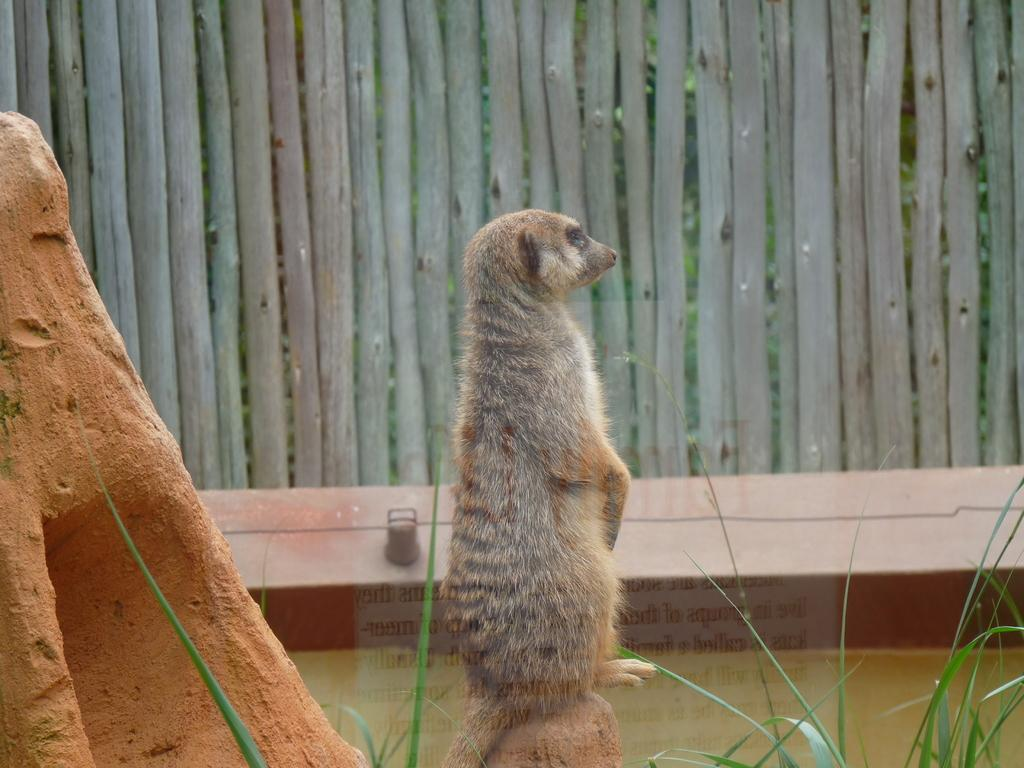What type of animal is in the image? There is an animal in the image, but we cannot determine the specific type from the provided facts. What colors are present on the animal? The animal is grey and white in color. What is the brown object in the image? We cannot determine the nature of the brown object from the provided facts. What type of vegetation is visible in the image? There is green grass in the image. What can be seen in the background of the image? There is wooden fencing in the background of the image. What type of curtain can be seen hanging from the wooden fencing in the image? There is no curtain present in the image; only green grass, wooden fencing, and an animal are visible. How many baseballs can be seen in the image? There are no baseballs present in the image. 